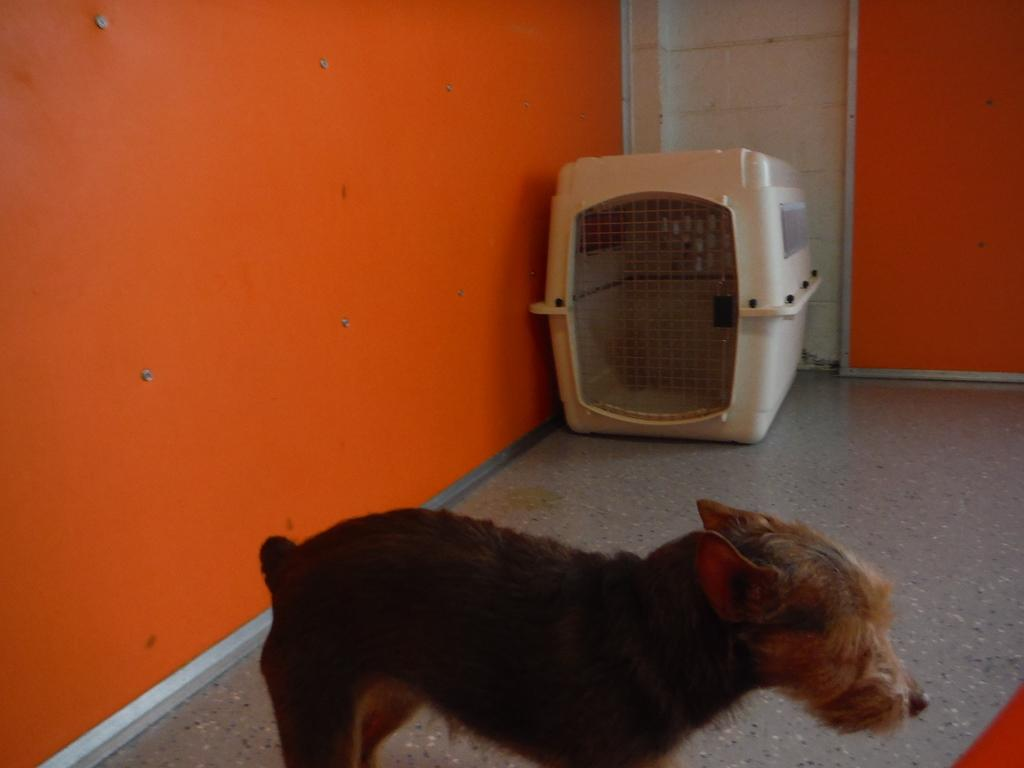What type of animal is in the image? There is a dog in the image. Can you describe the background of the image? The dog is standing in front of an orange wall. What can be seen in the background of the image? There is a cage in the background of the image. What type of needle is the dog using to sew the earth in the image? There is no needle or sewing activity involving the earth present in the image. What flavor of ice cream is the dog holding in the image? There is no ice cream present in the image. 